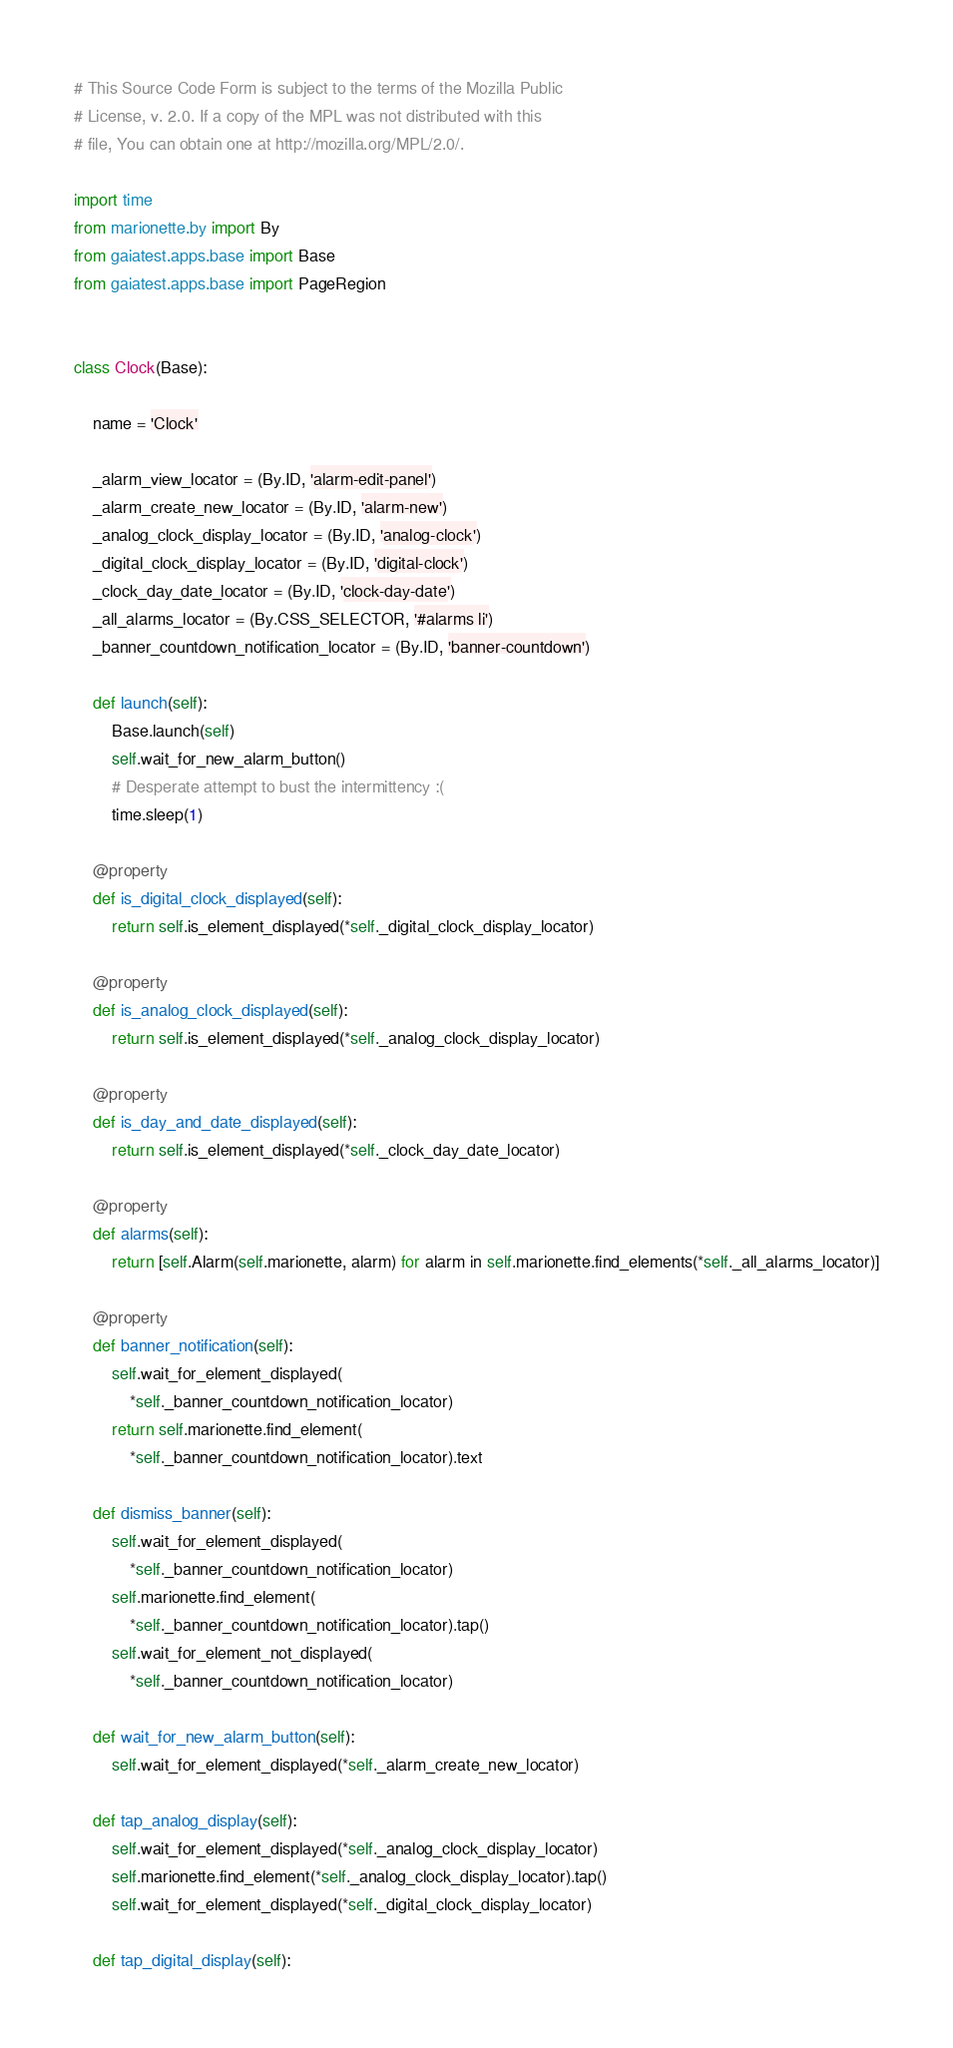<code> <loc_0><loc_0><loc_500><loc_500><_Python_># This Source Code Form is subject to the terms of the Mozilla Public
# License, v. 2.0. If a copy of the MPL was not distributed with this
# file, You can obtain one at http://mozilla.org/MPL/2.0/.

import time
from marionette.by import By
from gaiatest.apps.base import Base
from gaiatest.apps.base import PageRegion


class Clock(Base):

    name = 'Clock'

    _alarm_view_locator = (By.ID, 'alarm-edit-panel')
    _alarm_create_new_locator = (By.ID, 'alarm-new')
    _analog_clock_display_locator = (By.ID, 'analog-clock')
    _digital_clock_display_locator = (By.ID, 'digital-clock')
    _clock_day_date_locator = (By.ID, 'clock-day-date')
    _all_alarms_locator = (By.CSS_SELECTOR, '#alarms li')
    _banner_countdown_notification_locator = (By.ID, 'banner-countdown')

    def launch(self):
        Base.launch(self)
        self.wait_for_new_alarm_button()
        # Desperate attempt to bust the intermittency :(
        time.sleep(1)

    @property
    def is_digital_clock_displayed(self):
        return self.is_element_displayed(*self._digital_clock_display_locator)

    @property
    def is_analog_clock_displayed(self):
        return self.is_element_displayed(*self._analog_clock_display_locator)

    @property
    def is_day_and_date_displayed(self):
        return self.is_element_displayed(*self._clock_day_date_locator)

    @property
    def alarms(self):
        return [self.Alarm(self.marionette, alarm) for alarm in self.marionette.find_elements(*self._all_alarms_locator)]

    @property
    def banner_notification(self):
        self.wait_for_element_displayed(
            *self._banner_countdown_notification_locator)
        return self.marionette.find_element(
            *self._banner_countdown_notification_locator).text

    def dismiss_banner(self):
        self.wait_for_element_displayed(
            *self._banner_countdown_notification_locator)
        self.marionette.find_element(
            *self._banner_countdown_notification_locator).tap()
        self.wait_for_element_not_displayed(
            *self._banner_countdown_notification_locator)

    def wait_for_new_alarm_button(self):
        self.wait_for_element_displayed(*self._alarm_create_new_locator)

    def tap_analog_display(self):
        self.wait_for_element_displayed(*self._analog_clock_display_locator)
        self.marionette.find_element(*self._analog_clock_display_locator).tap()
        self.wait_for_element_displayed(*self._digital_clock_display_locator)

    def tap_digital_display(self):</code> 